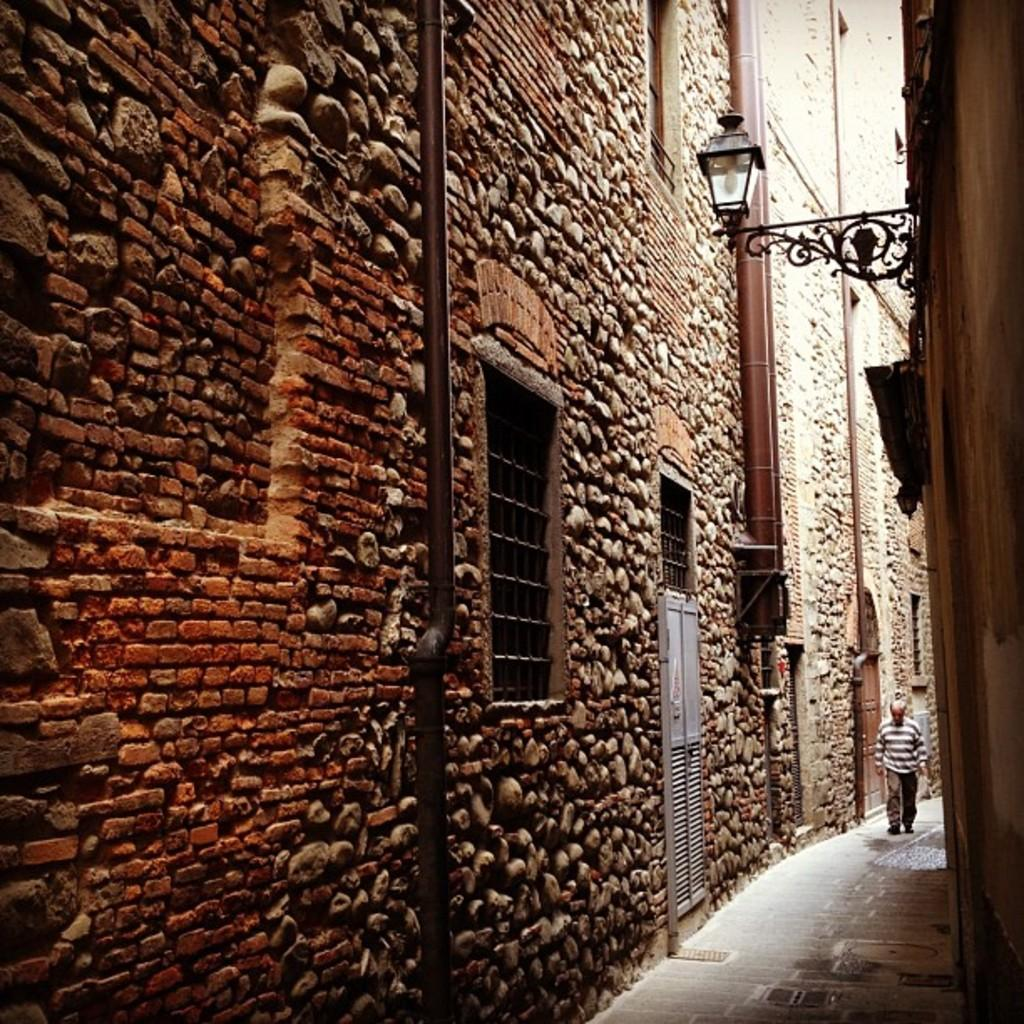What type of structure is visible in the image? There is a building wall in the image. What can be seen attached to the building wall? There are pipes, windows, and doors visible in the image. What type of lighting is present in the image? There is a lamp in the image. Is there any sign of human presence in the image? Yes, there is a person on the road in the image. What time of day was the image taken? The image was taken during the day. How does the person on the road kick the wound in the image? There is no person kicking a wound in the image; the person is simply standing on the road. 